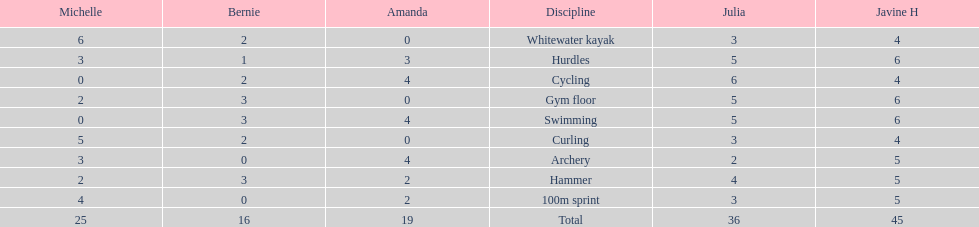What is the last discipline listed on this chart? 100m sprint. 